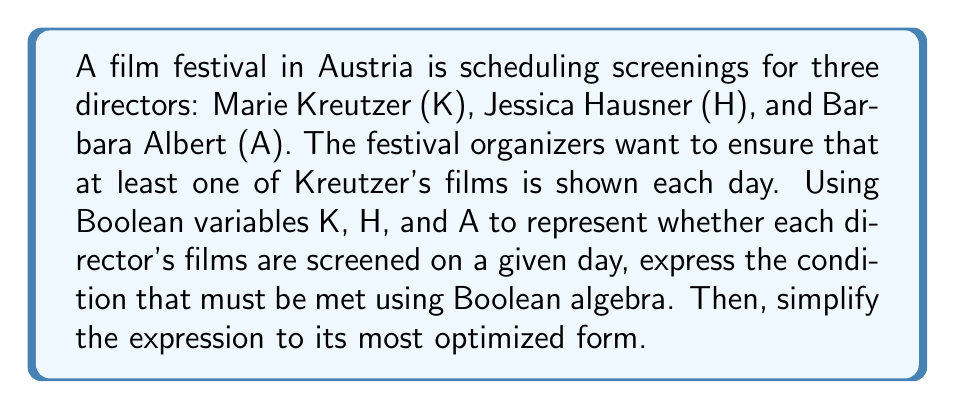Can you answer this question? Let's approach this step-by-step:

1. We need to ensure that Kreutzer's films are always shown, with the option of showing the other directors' films. This can be expressed as:

   $$ K \cdot (H + \overline{H}) \cdot (A + \overline{A}) $$

2. Apply the identity property of Boolean algebra:
   $$ X + \overline{X} = 1 $$

   So, our expression becomes:
   $$ K \cdot 1 \cdot 1 $$

3. Apply the identity property of Boolean multiplication:
   $$ X \cdot 1 = X $$

   Our final simplified expression is:
   $$ K $$

This means that to satisfy the condition, we only need to ensure that Kreutzer's films (K) are shown each day, regardless of whether Hausner's (H) or Albert's (A) films are screened.
Answer: $K$ 